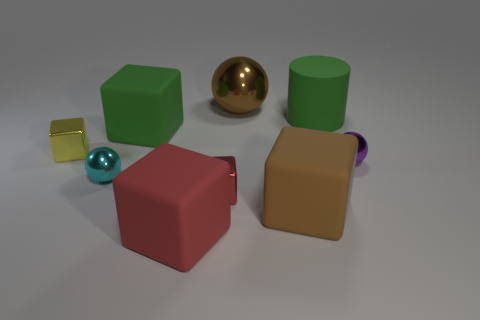Subtract all red blocks. How many were subtracted if there are1red blocks left? 1 Subtract all small cubes. How many cubes are left? 3 Subtract all purple balls. How many red blocks are left? 2 Add 1 small shiny things. How many objects exist? 10 Subtract all yellow blocks. How many blocks are left? 4 Subtract 3 blocks. How many blocks are left? 2 Subtract all big yellow rubber objects. Subtract all cyan balls. How many objects are left? 8 Add 1 brown things. How many brown things are left? 3 Add 5 large red cubes. How many large red cubes exist? 6 Subtract 1 brown blocks. How many objects are left? 8 